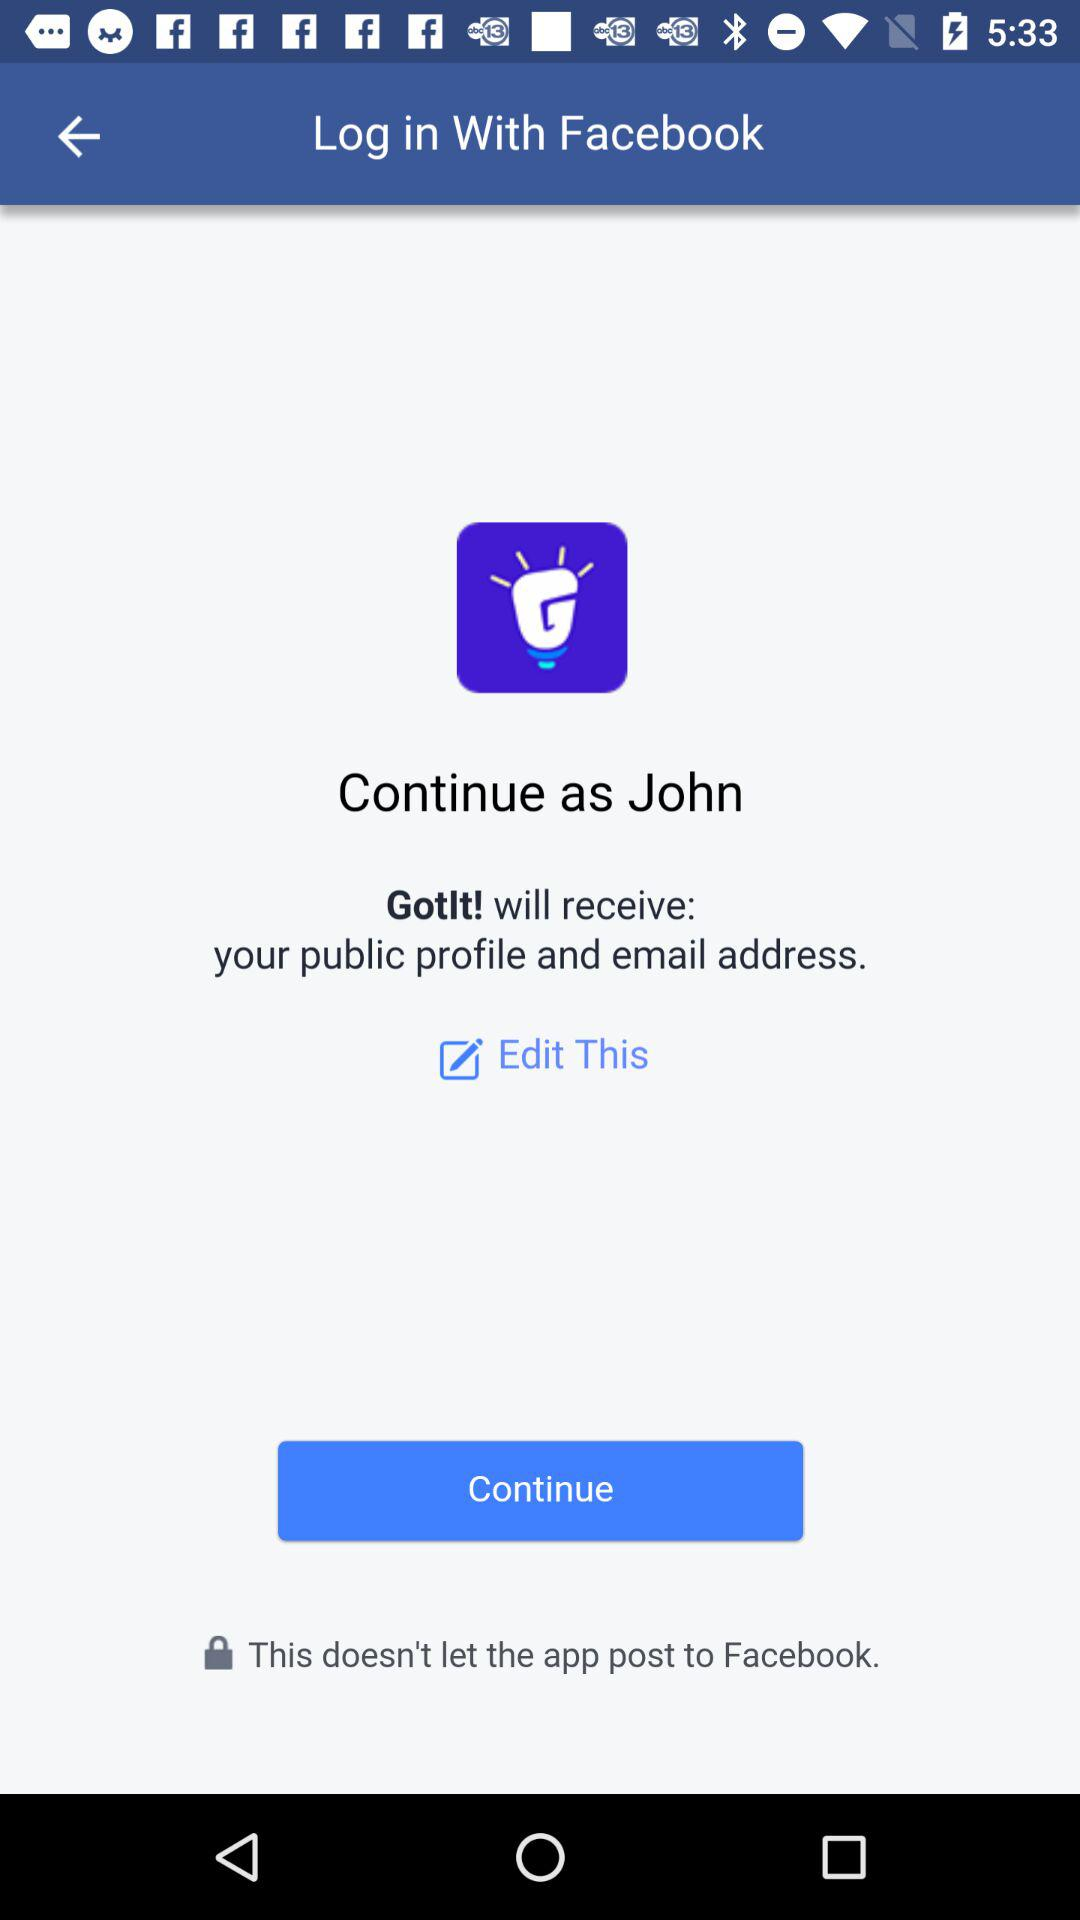What is the user name? The user name is John. 